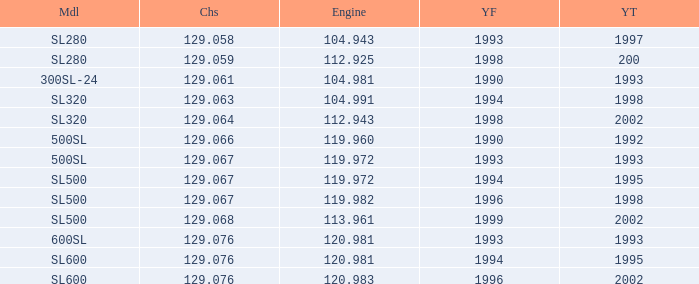Which Year To has an Engine of 119.972, and a Chassis smaller than 129.067? None. 